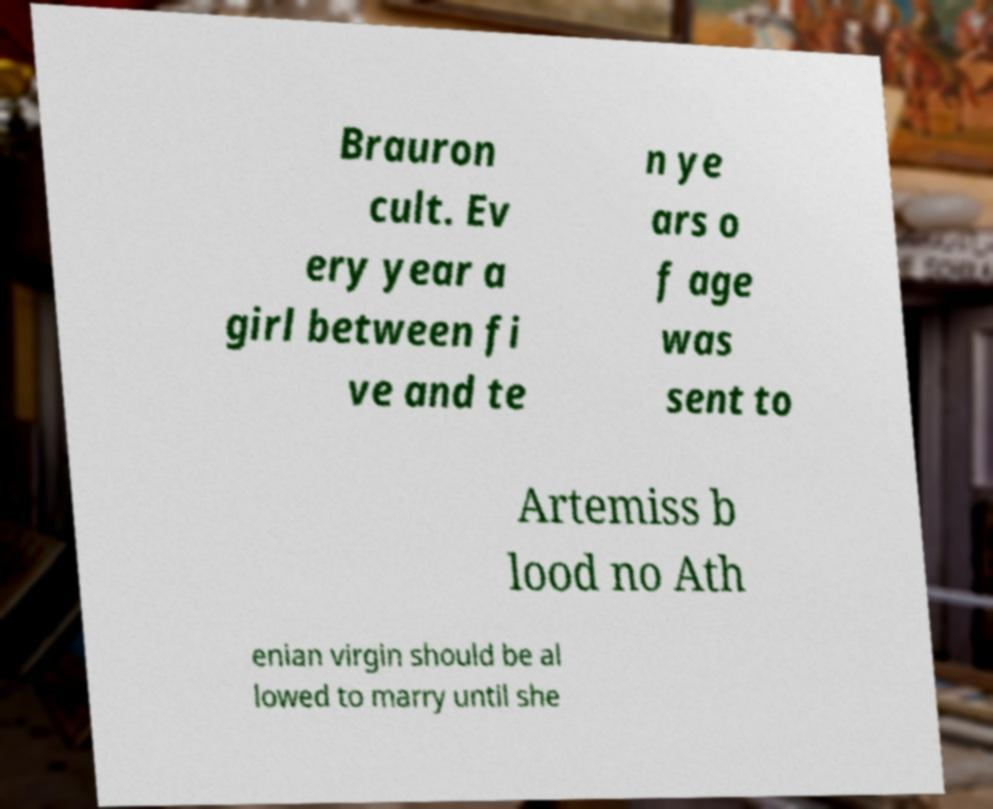There's text embedded in this image that I need extracted. Can you transcribe it verbatim? Brauron cult. Ev ery year a girl between fi ve and te n ye ars o f age was sent to Artemiss b lood no Ath enian virgin should be al lowed to marry until she 